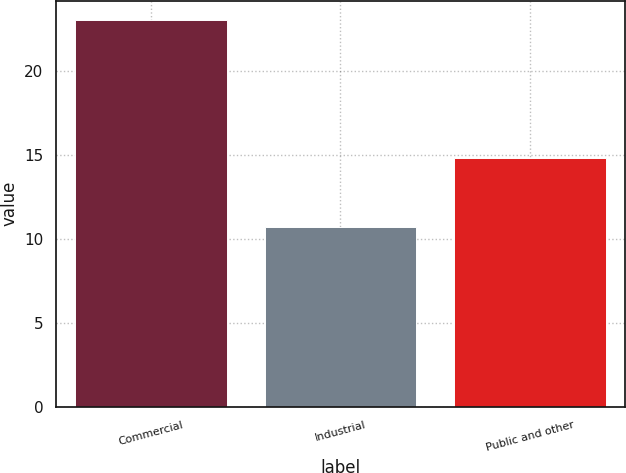Convert chart. <chart><loc_0><loc_0><loc_500><loc_500><bar_chart><fcel>Commercial<fcel>Industrial<fcel>Public and other<nl><fcel>23<fcel>10.7<fcel>14.8<nl></chart> 